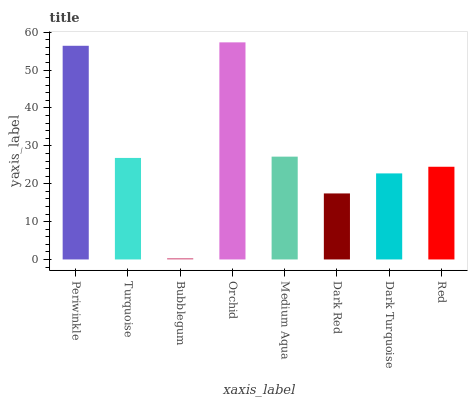Is Turquoise the minimum?
Answer yes or no. No. Is Turquoise the maximum?
Answer yes or no. No. Is Periwinkle greater than Turquoise?
Answer yes or no. Yes. Is Turquoise less than Periwinkle?
Answer yes or no. Yes. Is Turquoise greater than Periwinkle?
Answer yes or no. No. Is Periwinkle less than Turquoise?
Answer yes or no. No. Is Turquoise the high median?
Answer yes or no. Yes. Is Red the low median?
Answer yes or no. Yes. Is Periwinkle the high median?
Answer yes or no. No. Is Turquoise the low median?
Answer yes or no. No. 